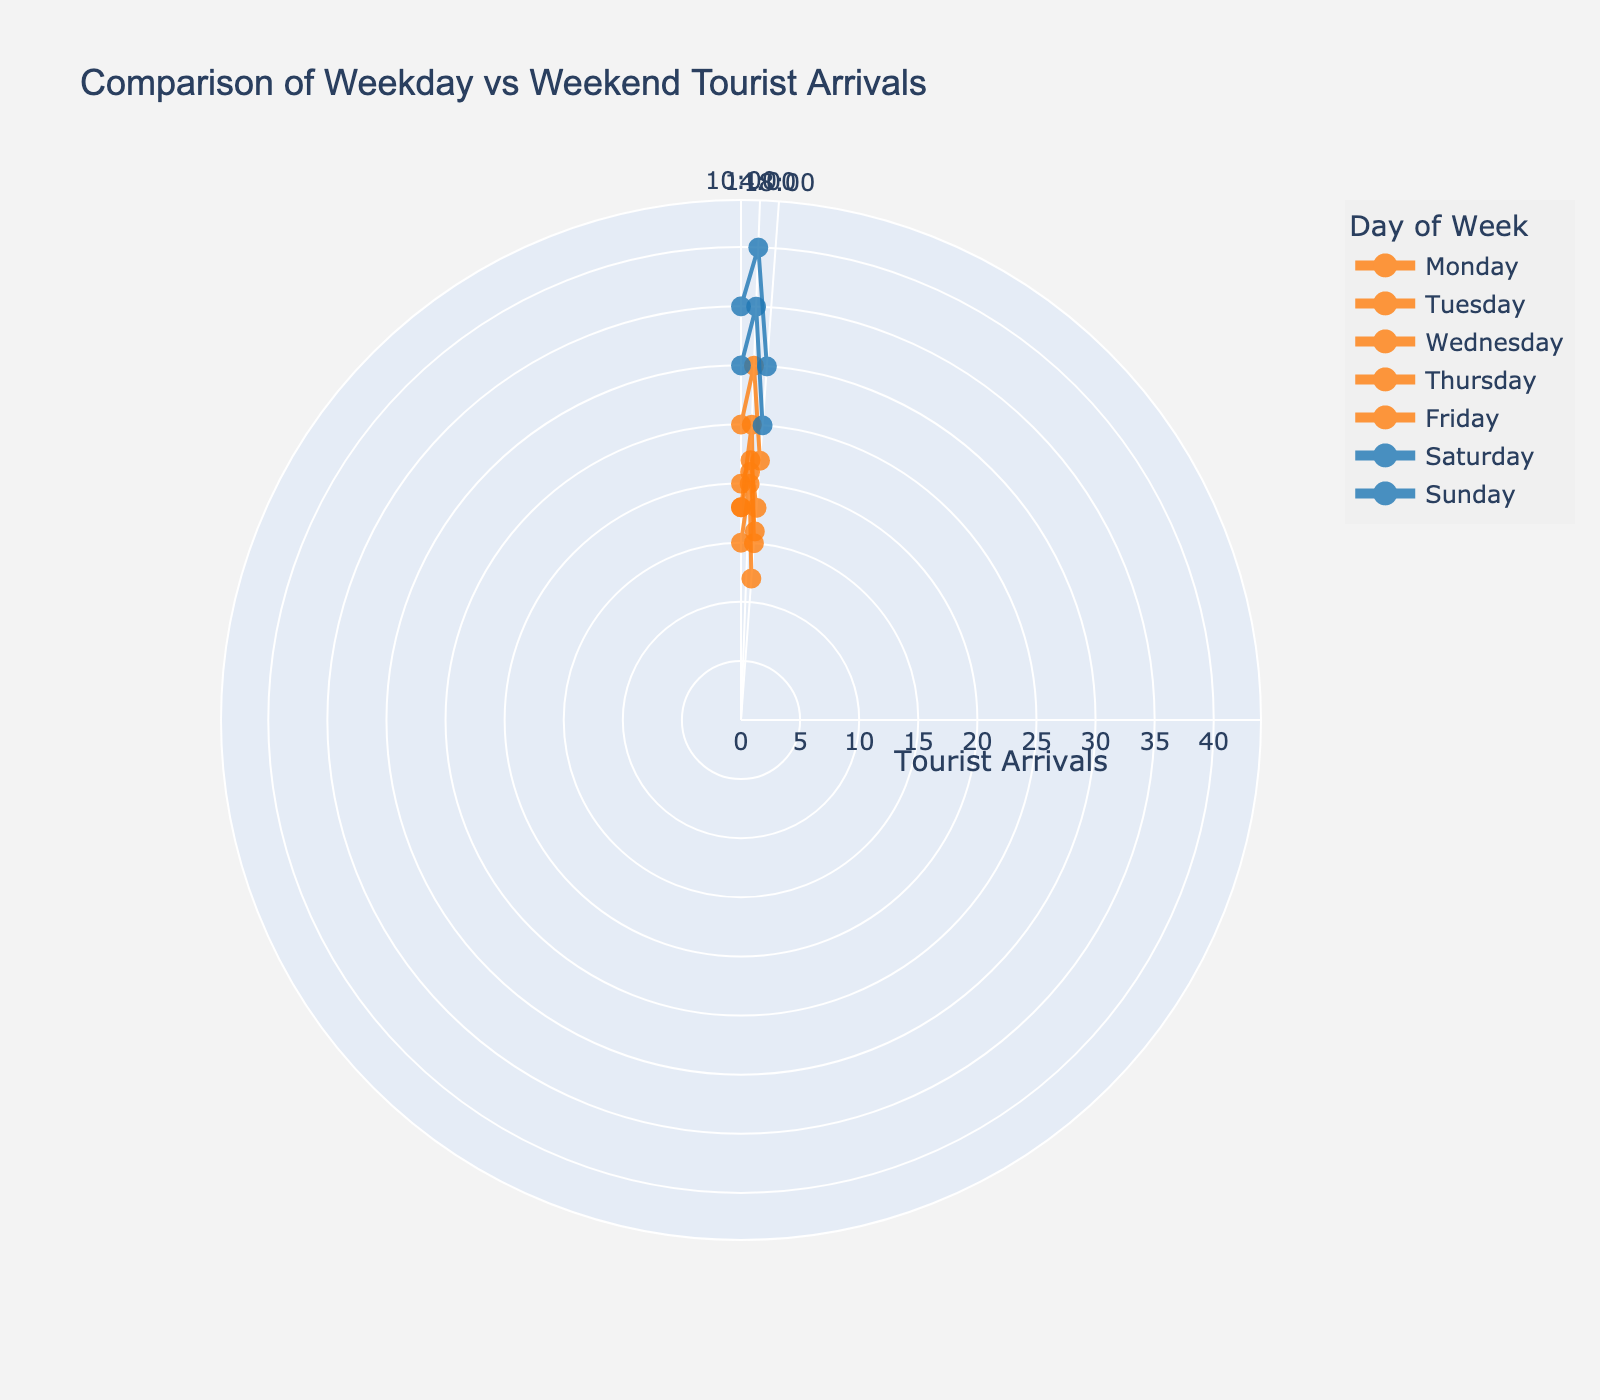What is the title of the figure? The title of the figure is prominently displayed at the top. It reads "Comparison of Weekday vs Weekend Tourist Arrivals".
Answer: Comparison of Weekday vs Weekend Tourist Arrivals How many data points are there for Friday? Each day has data points for three different times (10:00, 14:00, 18:00). By looking at Friday, we can count these three data points corresponding to the three times.
Answer: 3 What time has the highest tourist arrival on Saturday? Looking at the data points plotted for Saturday, identify the time with the highest radial distance (i.e., the data point farthest from the center). The 14:00 data point has the highest radial distance.
Answer: 14:00 Which day of the week has the highest tourist arrival overall? Visually inspect the plot to find the radial distance of the data points across all days. The highest radial distance corresponds to Saturday at 14:00.
Answer: Saturday Compare the tourist arrivals at 18:00 between Wednesday and Sunday. Which day has more arrivals? Locate the data points for 18:00 on both Wednesday and Sunday. The radial distances indicate the number of arrivals. Sunday has a greater radial distance than Wednesday.
Answer: Sunday What is the average number of tourist arrivals at 14:00 across weekdays (Monday to Friday)? Sum the arrivals at 14:00 for Monday (20), Tuesday (25), Wednesday (22), Thursday (21), and Friday (30). The total is 118. Divide by 5 (number of weekdays) to get the average. (20+25+22+21+30)/5 = 23.6
Answer: 23.6 What colors are used to represent weekdays and weekends? The colors assigned to the data points indicate whether it is a weekday or a weekend. Weekdays are represented by an orange color and weekends by a blue color.
Answer: Weekdays: orange, Weekends: blue How do tourist arrivals on weekends compare to weekdays at 10:00? Compare the radial distances at 10:00 for weekday and weekend days. Weekday arrivals range between 15 to 25, while arrivals on weekends are 35 and 30, which are higher.
Answer: Higher on weekends What’s the total number of tourist arrivals for Monday? Sum the tourist arrivals for Monday at 10:00 (15), 14:00 (20), and 18:00 (12). 15 + 20 + 12 = 47
Answer: 47 